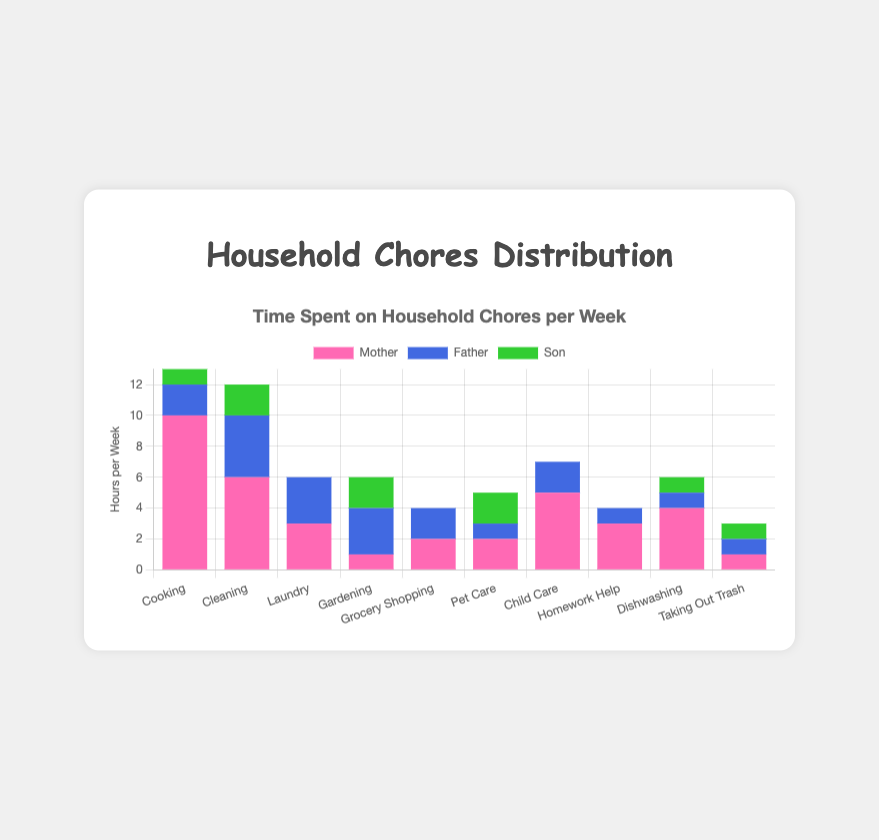Which chore does the mother spend the most time on? The highest bar for the mother is "Cooking", where she spends 10 hours per week.
Answer: Cooking Who spends the least amount of time on Pet Care? Looking at the bar heights for Pet Care, the father spends the least amount of time with 1 hour.
Answer: Father What is the total amount of time spent by the son on all chores? Add the hours contributed by the son for each chore: 1 (Cooking) + 2 (Cleaning) + 0 (Laundry) + 2 (Gardening) + 0 (Grocery Shopping) + 2 (Pet Care) + 0 (Child Care) + 0 (Homework Help) + 1 (Dishwashing) + 1 (Taking Out Trash) = 9
Answer: 9 Compare the time the mother and father spend on Cleaning. The mother's bar for Cleaning shows 6 hours, and the father's bar shows 4 hours. The mother spends more time.
Answer: Mother Which chores have equal hours contributed by the mother and father? Identifying chores where the bars for the mother and father are equal: Laundry (3 hours each), Grocery Shopping (2 hours each), and Taking Out Trash (1 hour each).
Answer: Laundry, Grocery Shopping, Taking Out Trash How many chores does the son contribute to more than 1 hour per week? Count the number of chores where the son's contribution is more than 1 hour: Cleaning (2 hours), Gardening (2 hours), Pet Care (2 hours), Dishwashing (1 hour counts, but is considered as just 1).
Answer: 3 How much more time does the mother spend on Cooking than the father? Subtract the father's time on Cooking from the mother's time: 10 (Mother) - 2 (Father) = 8
Answer: 8 Who spends the most time on Homework Help and how much time? The highest bar for Homework Help belongs to the mother at 3 hours per week.
Answer: Mother What is the average time spent by all family members on Gardening? Sum the hours for Gardening and divide by the number of family members: (1 + 3 + 2) / 3 = 6 / 3 = 2
Answer: 2 Identify which family member spends the least time on all chores combined. Add the total hours for each member across all chores: Mother (10+6+3+1+2+2+5+3+4+1=37), Father (2+4+3+3+2+1+2+1+1+1=20), Son (1+2+0+2+0+2+0+0+1+1=9), the son has the least total hours.
Answer: Son 